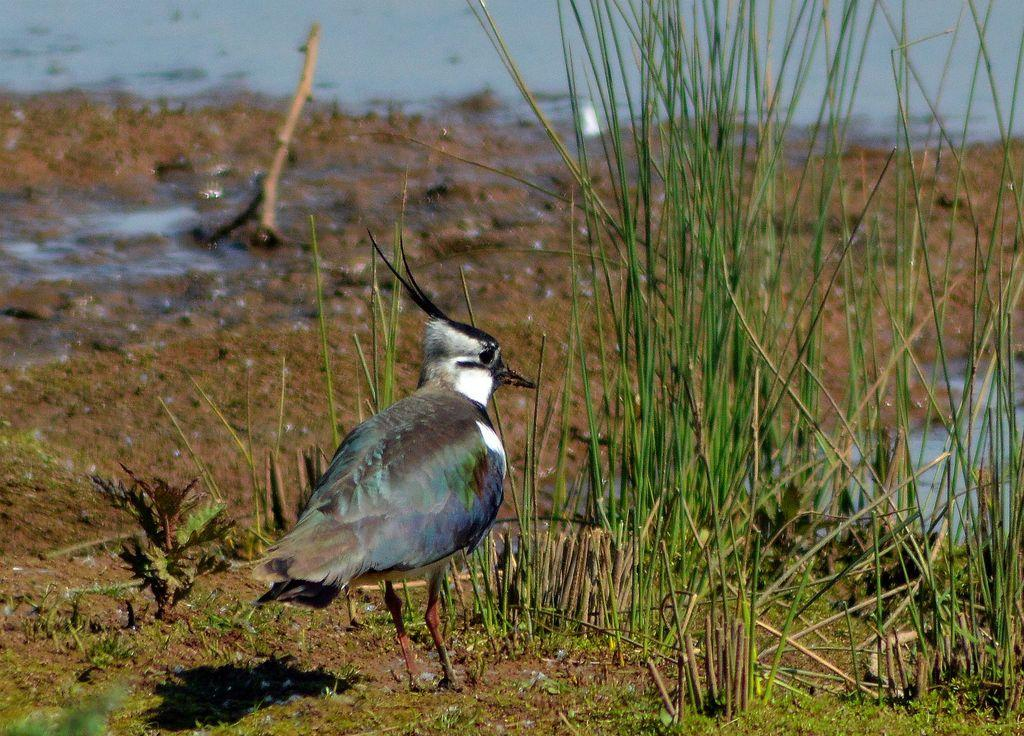What type of animal can be seen in the image? There is a bird in the image. What type of vegetation is present in the image? There is grass in the image. What body of water is visible in the image? There is a lake in the image. What is the bird's digestion process like in the image? There is no information about the bird's digestion process in the image. How steep is the hill in the image? There is no hill present in the image. 